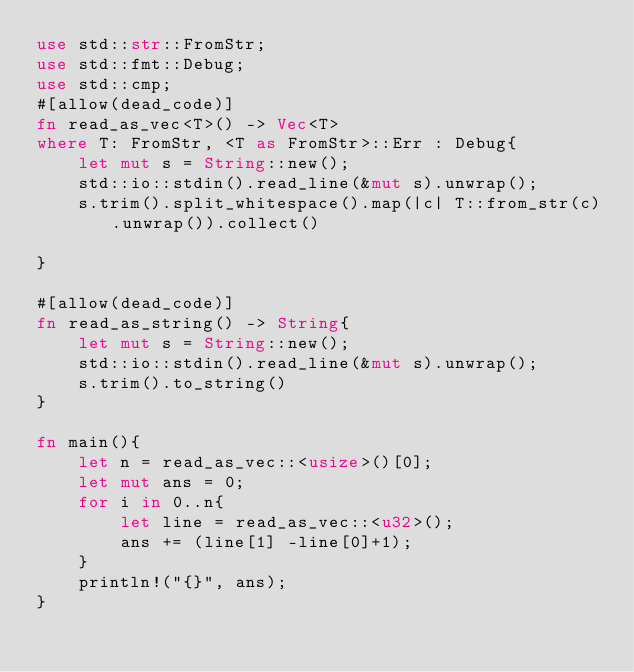<code> <loc_0><loc_0><loc_500><loc_500><_Rust_>use std::str::FromStr;
use std::fmt::Debug;
use std::cmp;
#[allow(dead_code)]
fn read_as_vec<T>() -> Vec<T>
where T: FromStr, <T as FromStr>::Err : Debug{
    let mut s = String::new();
    std::io::stdin().read_line(&mut s).unwrap();
    s.trim().split_whitespace().map(|c| T::from_str(c).unwrap()).collect()

}

#[allow(dead_code)]
fn read_as_string() -> String{
    let mut s = String::new();
    std::io::stdin().read_line(&mut s).unwrap();
    s.trim().to_string()
}

fn main(){
    let n = read_as_vec::<usize>()[0];
    let mut ans = 0;
    for i in 0..n{
        let line = read_as_vec::<u32>();
        ans += (line[1] -line[0]+1);
    }
    println!("{}", ans);
}
</code> 